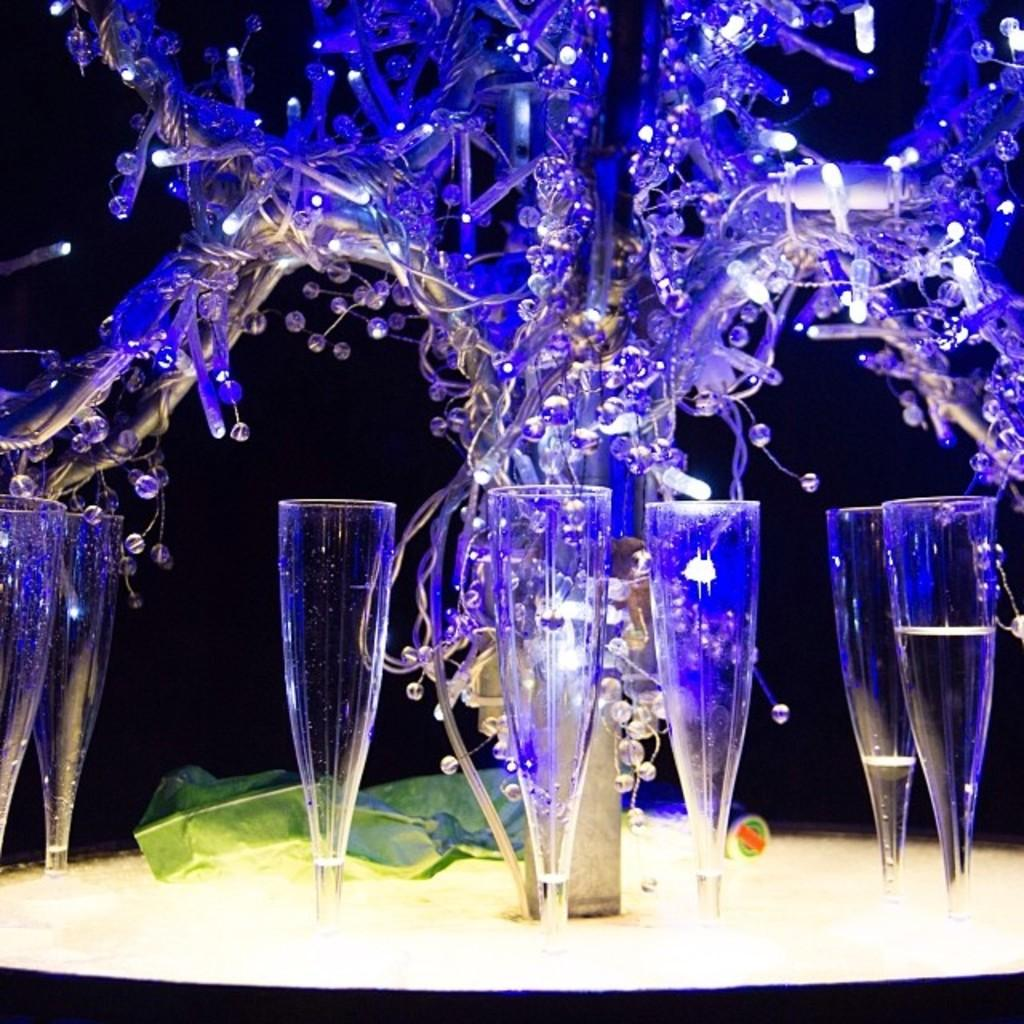What object is present in the image that can hold multiple items? There is a tray in the image that can hold multiple items. What type of items are on the tray? There are many glasses on the tray. What is the central feature of the tray? There is a pole with decorative items and lights in the center of the tray. What is the color of the item on the tray? There is a green color thing on the tray. Can you describe the activity of the flock of birds in the cellar in the image? There is no mention of a flock of birds or a cellar in the image; the image features a tray with glasses, a pole with decorative items and lights, and a green item. 